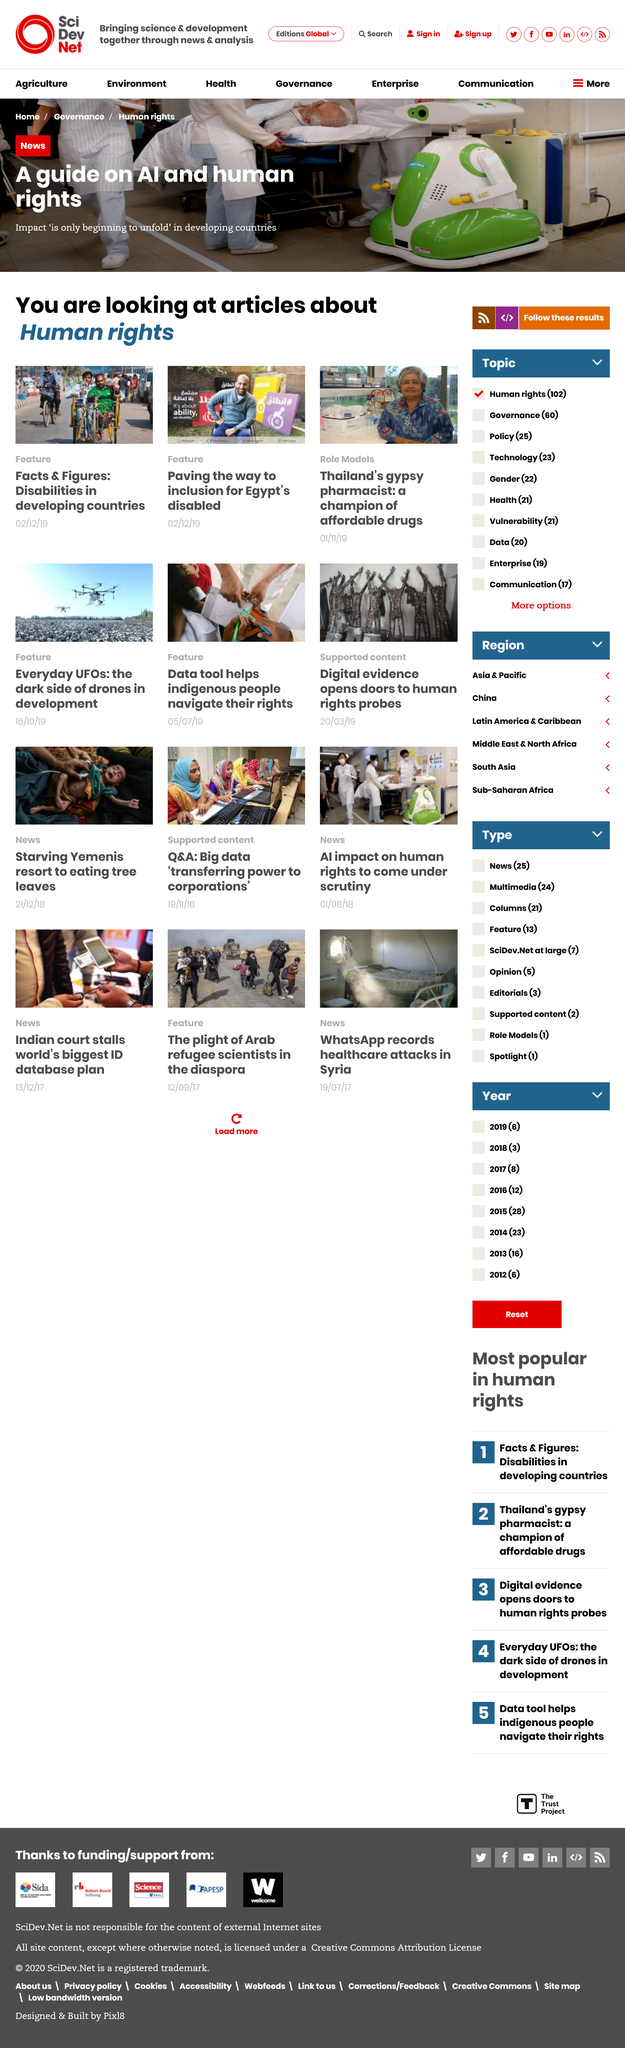Give some essential details in this illustration. The featured articles cover the topic of human rights. On December 2nd, 2019, the feature 'Paving the way to inclusion for Egypt's disabled' was published. The "Facts & Figures: Disabilities in developing countries" feature was published on December 2nd, 2019. 